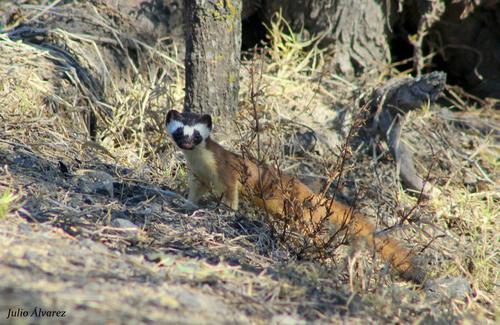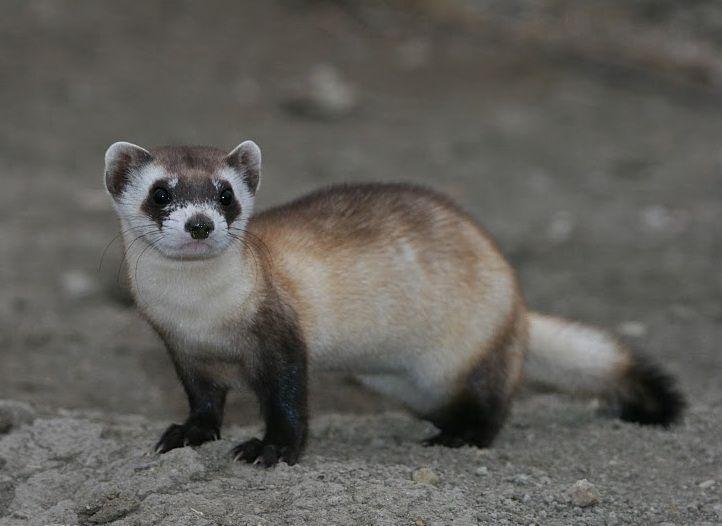The first image is the image on the left, the second image is the image on the right. Analyze the images presented: Is the assertion "One image includes a ferret with closed eyes and open mouth on textured white bedding." valid? Answer yes or no. No. The first image is the image on the left, the second image is the image on the right. For the images displayed, is the sentence "Two adult ferrets can be seen." factually correct? Answer yes or no. Yes. 